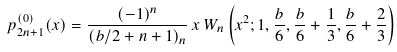<formula> <loc_0><loc_0><loc_500><loc_500>p _ { 2 n + 1 } ^ { ( 0 ) } ( x ) = \frac { ( - 1 ) ^ { n } } { ( b / 2 + n + 1 ) _ { n } } \, x \, W _ { n } \left ( x ^ { 2 } ; 1 , \frac { b } { 6 } , \frac { b } { 6 } + \frac { 1 } { 3 } , \frac { b } { 6 } + \frac { 2 } { 3 } \right )</formula> 